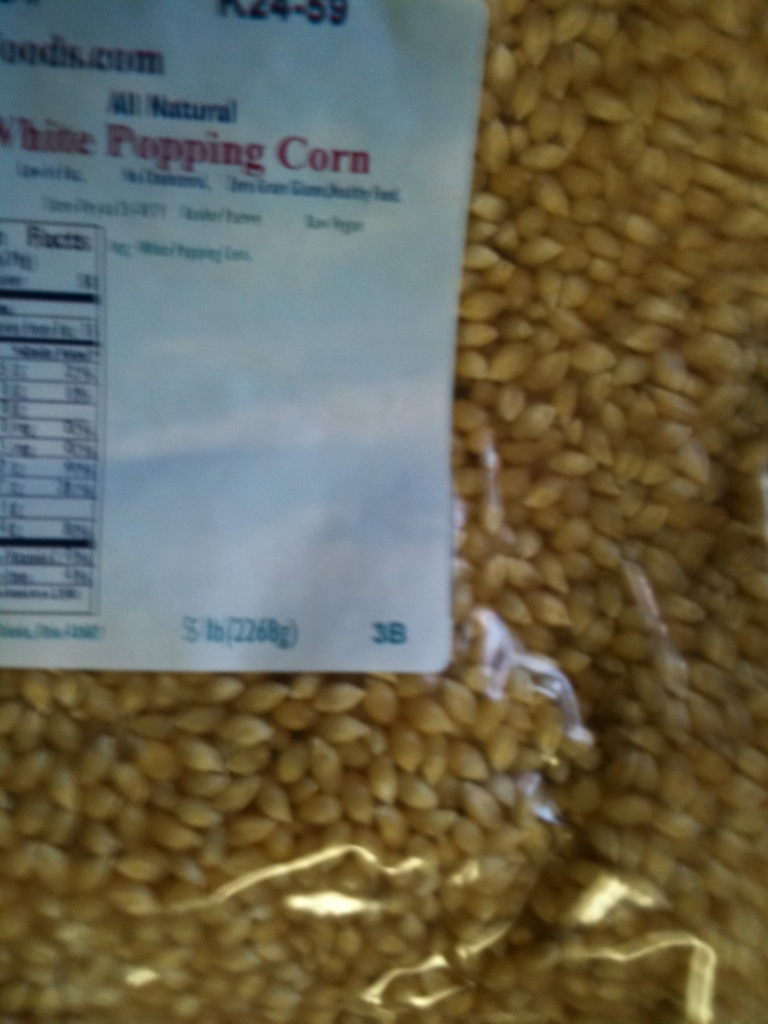Imagine if this package of popping corn had magical properties. What kind of magical popcorn could it make? Imagine if this popping corn could make magical popcorn! Each kernel would pop into not just fluffy snacks, but into mini flying popcorn beings that bring happiness and creativity wherever they go. Eating this magical popcorn might grant you temporary superpowers like the ability to fly or to speak with animals! The possibilities are as endless as your imagination. 